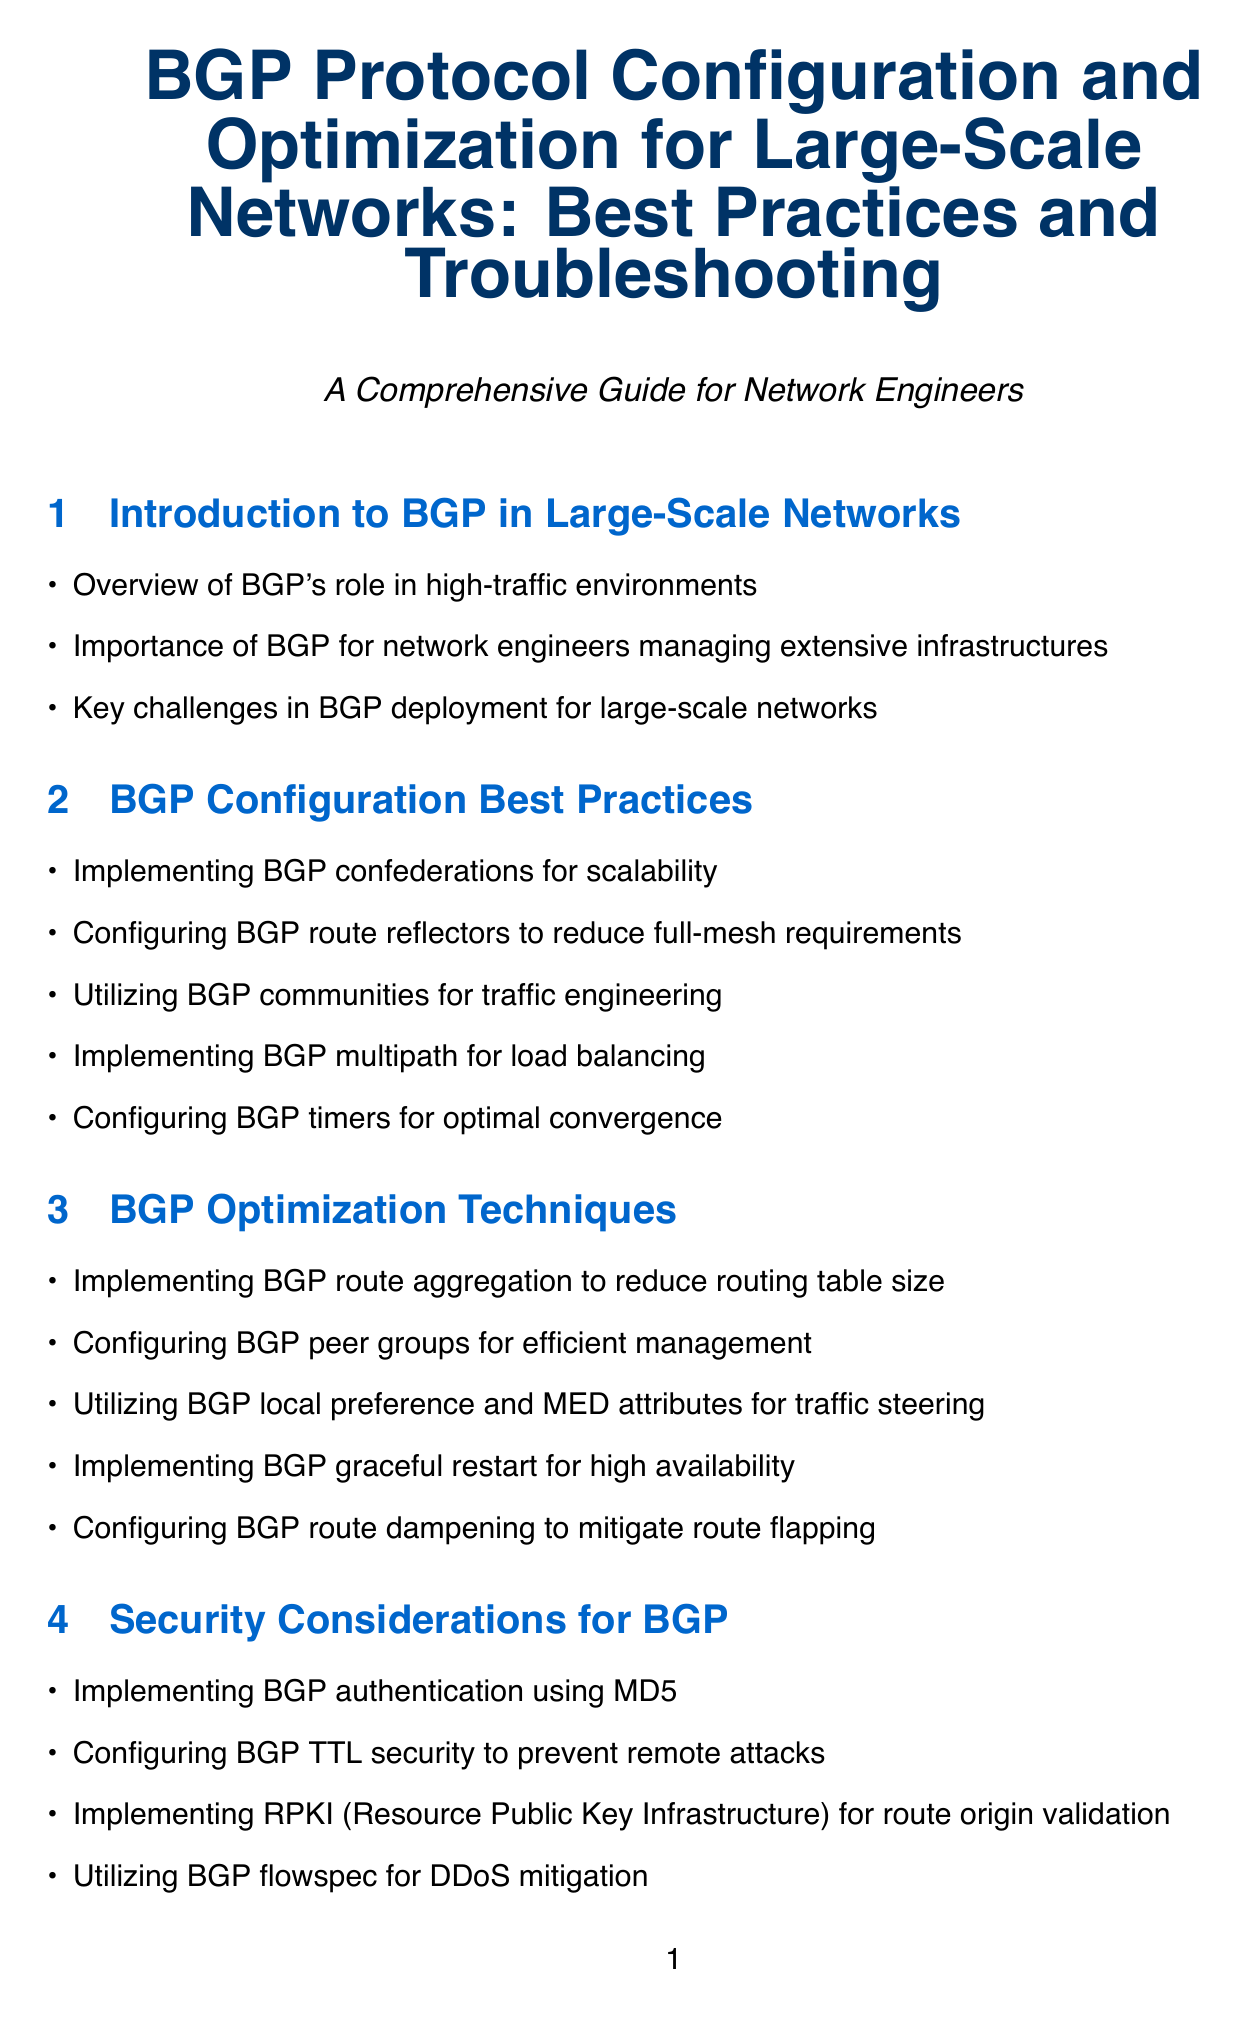What is the title of the manual? The title of the manual is stated at the beginning and serves as the main heading of the document.
Answer: BGP Protocol Configuration and Optimization for Large-Scale Networks: Best Practices and Troubleshooting What is one technique for optimizing BGP? The document lists several optimization techniques, and one of them is explicitly mentioned.
Answer: Implementing BGP route aggregation to reduce routing table size Which security mechanism uses MD5? The document specifies the security considerations related to BGP, including a specific authentication method.
Answer: Implementing BGP authentication using MD5 What does BGP stand for? The document refers to the protocol multiple times and provides its full form in the title.
Answer: Border Gateway Protocol What is a BGP configuration best practice? The document outlines various best practices, and this question asks for one example.
Answer: Configuring BGP route reflectors to reduce full-mesh requirements Which tool is used for programmable BGP implementations? The document includes a section on BGP tools and software, naming specific tools.
Answer: GoBGP What is a challenge mentioned in BGP deployment for large-scale networks? The document highlights challenges in the introduction section.
Answer: Key challenges in BGP deployment for large-scale networks What advanced BGP topic relates to SDN integration? The document discusses various advanced topics, including this particular one for SDN.
Answer: Implementing BGP-LS (Link State) for SDN integration 